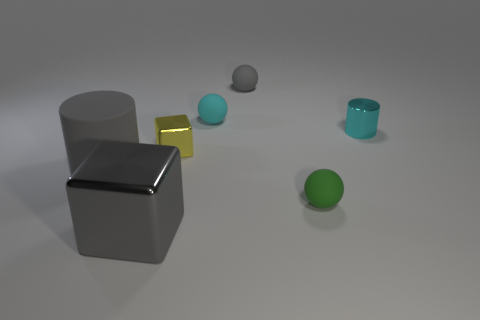Do the gray cube and the big object that is behind the green rubber object have the same material?
Your answer should be compact. No. Are there fewer gray matte balls in front of the green ball than small gray objects that are on the right side of the small gray object?
Make the answer very short. No. What number of small gray balls are the same material as the green sphere?
Ensure brevity in your answer.  1. There is a thing that is on the right side of the tiny rubber object in front of the cyan ball; are there any cyan rubber spheres left of it?
Provide a succinct answer. Yes. How many cylinders are large gray metal things or tiny green rubber objects?
Make the answer very short. 0. There is a yellow metallic thing; is its shape the same as the gray rubber object that is in front of the tiny cylinder?
Offer a very short reply. No. Is the number of small spheres that are in front of the green matte object less than the number of small green matte things?
Keep it short and to the point. Yes. Are there any gray balls in front of the small green matte object?
Make the answer very short. No. Is there a rubber object that has the same shape as the tiny cyan shiny object?
Provide a succinct answer. Yes. There is a gray rubber object that is the same size as the green matte object; what shape is it?
Make the answer very short. Sphere. 